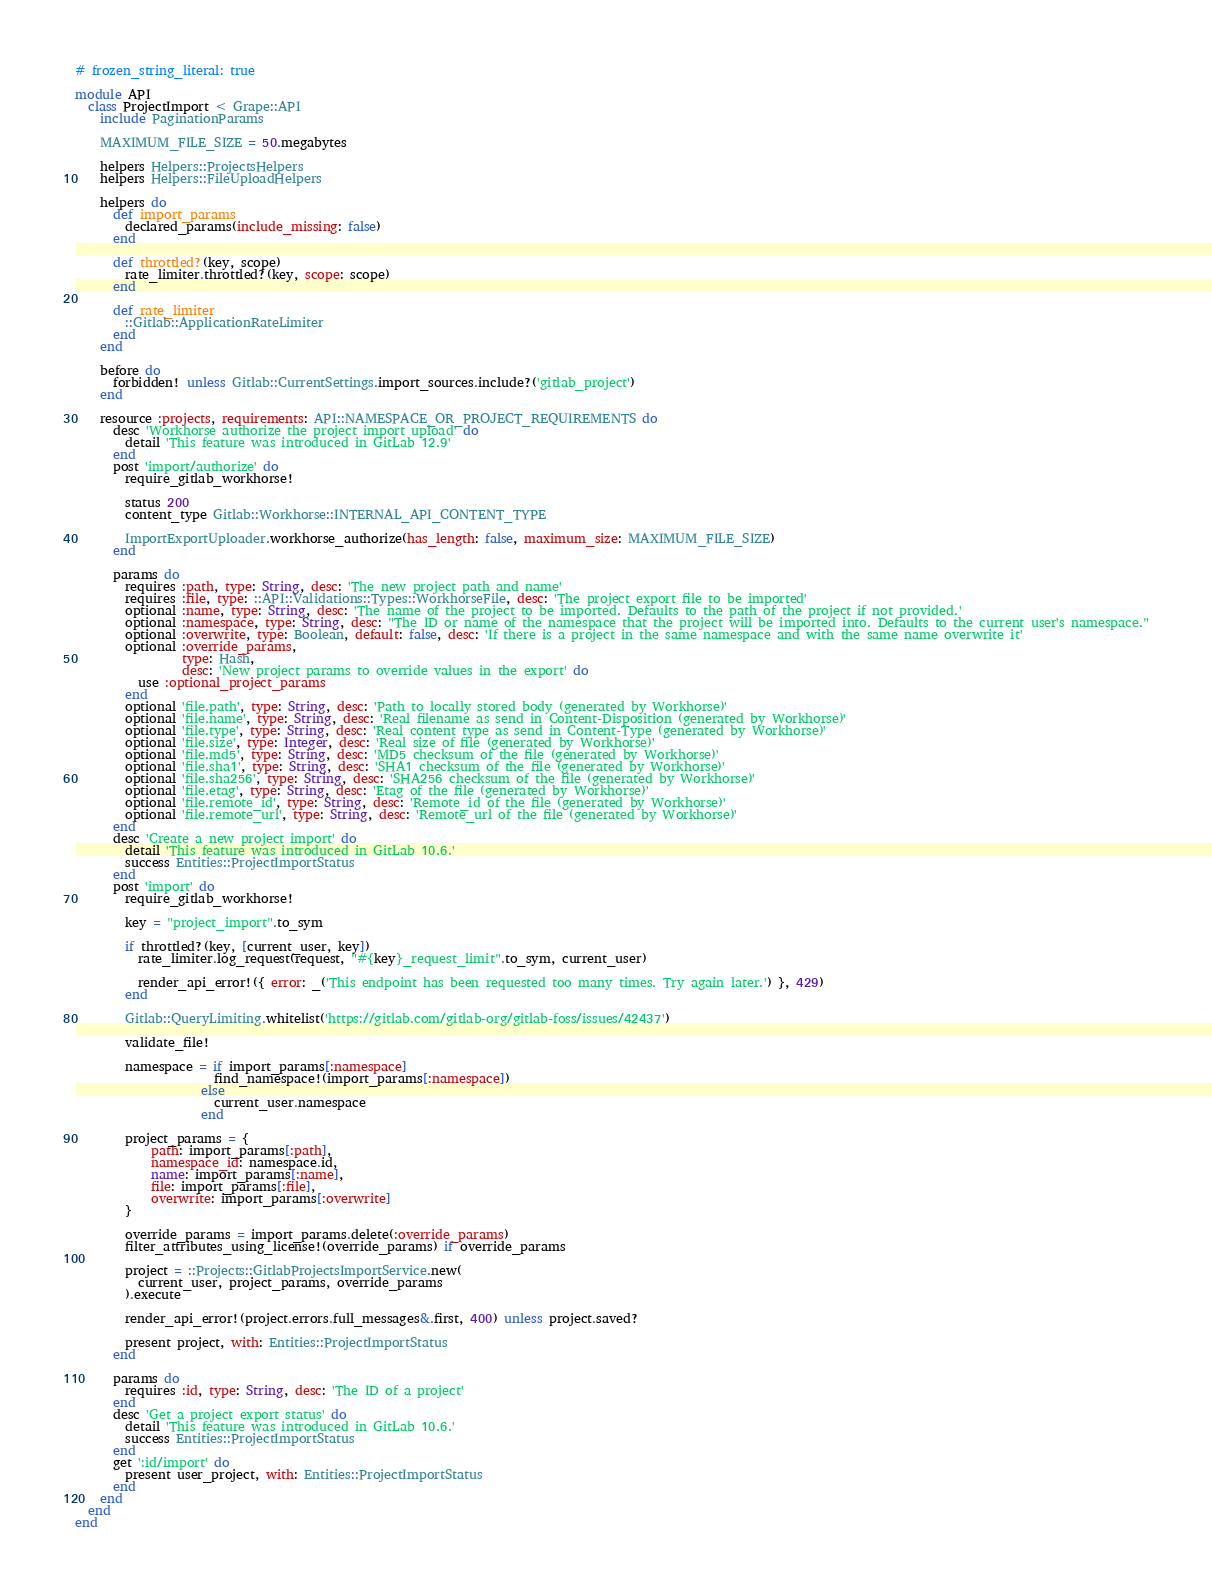<code> <loc_0><loc_0><loc_500><loc_500><_Ruby_># frozen_string_literal: true

module API
  class ProjectImport < Grape::API
    include PaginationParams

    MAXIMUM_FILE_SIZE = 50.megabytes

    helpers Helpers::ProjectsHelpers
    helpers Helpers::FileUploadHelpers

    helpers do
      def import_params
        declared_params(include_missing: false)
      end

      def throttled?(key, scope)
        rate_limiter.throttled?(key, scope: scope)
      end

      def rate_limiter
        ::Gitlab::ApplicationRateLimiter
      end
    end

    before do
      forbidden! unless Gitlab::CurrentSettings.import_sources.include?('gitlab_project')
    end

    resource :projects, requirements: API::NAMESPACE_OR_PROJECT_REQUIREMENTS do
      desc 'Workhorse authorize the project import upload' do
        detail 'This feature was introduced in GitLab 12.9'
      end
      post 'import/authorize' do
        require_gitlab_workhorse!

        status 200
        content_type Gitlab::Workhorse::INTERNAL_API_CONTENT_TYPE

        ImportExportUploader.workhorse_authorize(has_length: false, maximum_size: MAXIMUM_FILE_SIZE)
      end

      params do
        requires :path, type: String, desc: 'The new project path and name'
        requires :file, type: ::API::Validations::Types::WorkhorseFile, desc: 'The project export file to be imported'
        optional :name, type: String, desc: 'The name of the project to be imported. Defaults to the path of the project if not provided.'
        optional :namespace, type: String, desc: "The ID or name of the namespace that the project will be imported into. Defaults to the current user's namespace."
        optional :overwrite, type: Boolean, default: false, desc: 'If there is a project in the same namespace and with the same name overwrite it'
        optional :override_params,
                 type: Hash,
                 desc: 'New project params to override values in the export' do
          use :optional_project_params
        end
        optional 'file.path', type: String, desc: 'Path to locally stored body (generated by Workhorse)'
        optional 'file.name', type: String, desc: 'Real filename as send in Content-Disposition (generated by Workhorse)'
        optional 'file.type', type: String, desc: 'Real content type as send in Content-Type (generated by Workhorse)'
        optional 'file.size', type: Integer, desc: 'Real size of file (generated by Workhorse)'
        optional 'file.md5', type: String, desc: 'MD5 checksum of the file (generated by Workhorse)'
        optional 'file.sha1', type: String, desc: 'SHA1 checksum of the file (generated by Workhorse)'
        optional 'file.sha256', type: String, desc: 'SHA256 checksum of the file (generated by Workhorse)'
        optional 'file.etag', type: String, desc: 'Etag of the file (generated by Workhorse)'
        optional 'file.remote_id', type: String, desc: 'Remote_id of the file (generated by Workhorse)'
        optional 'file.remote_url', type: String, desc: 'Remote_url of the file (generated by Workhorse)'
      end
      desc 'Create a new project import' do
        detail 'This feature was introduced in GitLab 10.6.'
        success Entities::ProjectImportStatus
      end
      post 'import' do
        require_gitlab_workhorse!

        key = "project_import".to_sym

        if throttled?(key, [current_user, key])
          rate_limiter.log_request(request, "#{key}_request_limit".to_sym, current_user)

          render_api_error!({ error: _('This endpoint has been requested too many times. Try again later.') }, 429)
        end

        Gitlab::QueryLimiting.whitelist('https://gitlab.com/gitlab-org/gitlab-foss/issues/42437')

        validate_file!

        namespace = if import_params[:namespace]
                      find_namespace!(import_params[:namespace])
                    else
                      current_user.namespace
                    end

        project_params = {
            path: import_params[:path],
            namespace_id: namespace.id,
            name: import_params[:name],
            file: import_params[:file],
            overwrite: import_params[:overwrite]
        }

        override_params = import_params.delete(:override_params)
        filter_attributes_using_license!(override_params) if override_params

        project = ::Projects::GitlabProjectsImportService.new(
          current_user, project_params, override_params
        ).execute

        render_api_error!(project.errors.full_messages&.first, 400) unless project.saved?

        present project, with: Entities::ProjectImportStatus
      end

      params do
        requires :id, type: String, desc: 'The ID of a project'
      end
      desc 'Get a project export status' do
        detail 'This feature was introduced in GitLab 10.6.'
        success Entities::ProjectImportStatus
      end
      get ':id/import' do
        present user_project, with: Entities::ProjectImportStatus
      end
    end
  end
end
</code> 